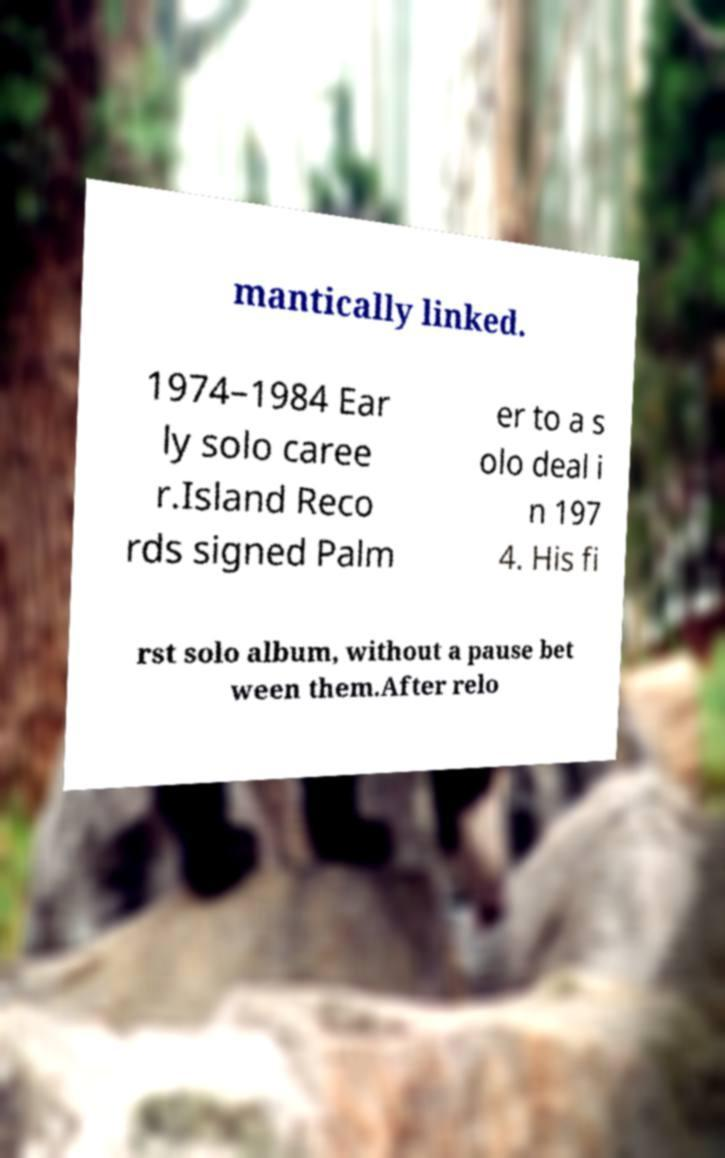For documentation purposes, I need the text within this image transcribed. Could you provide that? mantically linked. 1974–1984 Ear ly solo caree r.Island Reco rds signed Palm er to a s olo deal i n 197 4. His fi rst solo album, without a pause bet ween them.After relo 